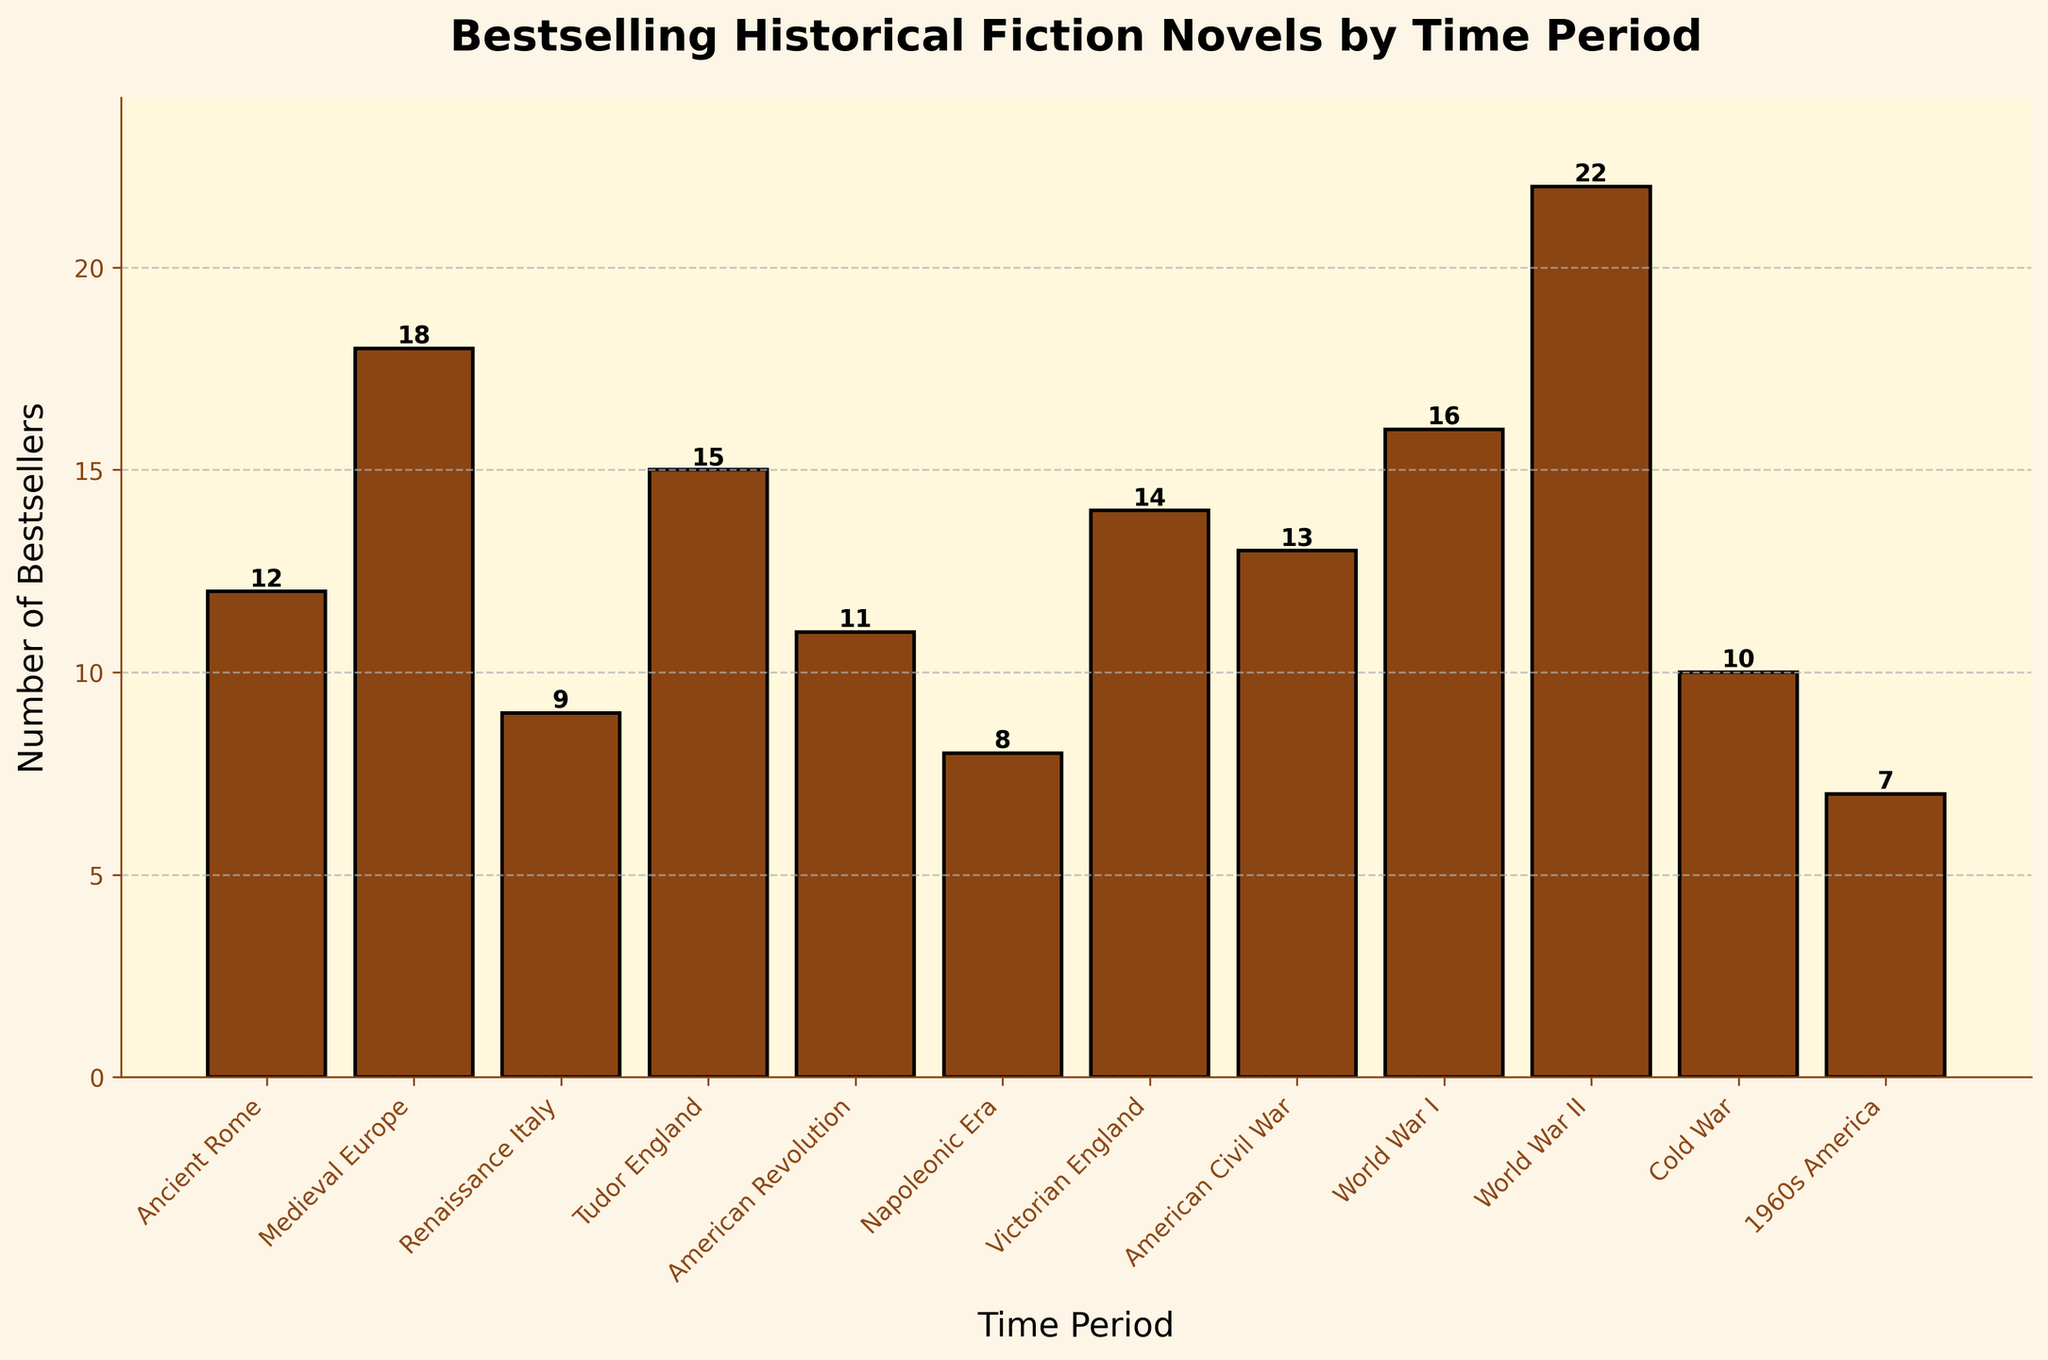What time period has the most bestselling historical fiction novels? By looking at the height of each bar, we can see that the bar for "World War II" is the tallest, indicating it has the most bestsellers.
Answer: World War II Which time periods have fewer than 10 bestselling novels? By observing the height of the bars and the value labels on top of each, we see that "Napoleonic Era" (8) and "1960s America" (7) have fewer than 10 bestsellers.
Answer: Napoleonic Era, 1960s America How many more bestselling novels are set in World War I compared to the Napoleonic Era? World War I has 16 bestsellers, and the Napoleonic Era has 8. The difference can be calculated as 16 - 8.
Answer: 8 What's the total number of bestsellers across Tudor England and Victorian England combined? Tudor England has 15 bestsellers and Victorian England has 14, so the sum is 15 + 14.
Answer: 29 Which time period has the second highest number of bestsellers after World War II, and how many? After World War II, "Medieval Europe" has the second highest bar with 18 bestsellers, as indicated by its height and value label.
Answer: Medieval Europe, 18 Are there more bestselling novels set in World War I or the American Civil War, and by how many? World War I has 16 bestsellers, and the American Civil War has 13. The difference is 16 - 13.
Answer: World War I, 3 What's the average number of bestsellers for "Ancient Rome," "Renaissance Italy," and the "Cold War?" Ancient Rome has 12, Renaissance Italy has 9, and the Cold War has 10. The average is calculated as (12 + 9 + 10) / 3.
Answer: 10.33 Which time periods have more than 15 bestsellers? The bars and labels show that "Medieval Europe" (18), "World War I" (16), and "World War II" (22) have more than 15 bestsellers.
Answer: Medieval Europe, World War I, World War II How many bestselling novels are set in the 20th century periods (World War I, World War II, Cold War, 1960s America)? Adding the values: World War I (16), World War II (22), Cold War (10), 1960s America (7), the total number of bestsellers is 16 + 22 + 10 + 7.
Answer: 55 